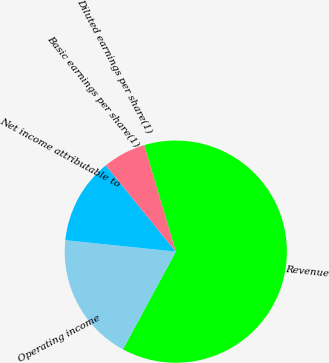Convert chart. <chart><loc_0><loc_0><loc_500><loc_500><pie_chart><fcel>Revenue<fcel>Operating income<fcel>Net income attributable to<fcel>Basic earnings per share(1)<fcel>Diluted earnings per share(1)<nl><fcel>62.5%<fcel>18.75%<fcel>12.5%<fcel>0.0%<fcel>6.25%<nl></chart> 